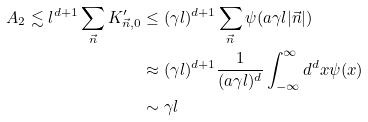<formula> <loc_0><loc_0><loc_500><loc_500>A _ { 2 } \lesssim l ^ { d + 1 } \sum _ { \vec { n } } K ^ { \prime } _ { \vec { n } , 0 } & \leq ( \gamma l ) ^ { d + 1 } \sum _ { \vec { n } } \psi ( a \gamma l | \vec { n } | ) \\ & \approx ( \gamma l ) ^ { d + 1 } \frac { 1 } { ( a \gamma l ) ^ { d } } \int _ { - \infty } ^ { \infty } d ^ { d } x \psi ( x ) \\ & \sim \gamma l</formula> 